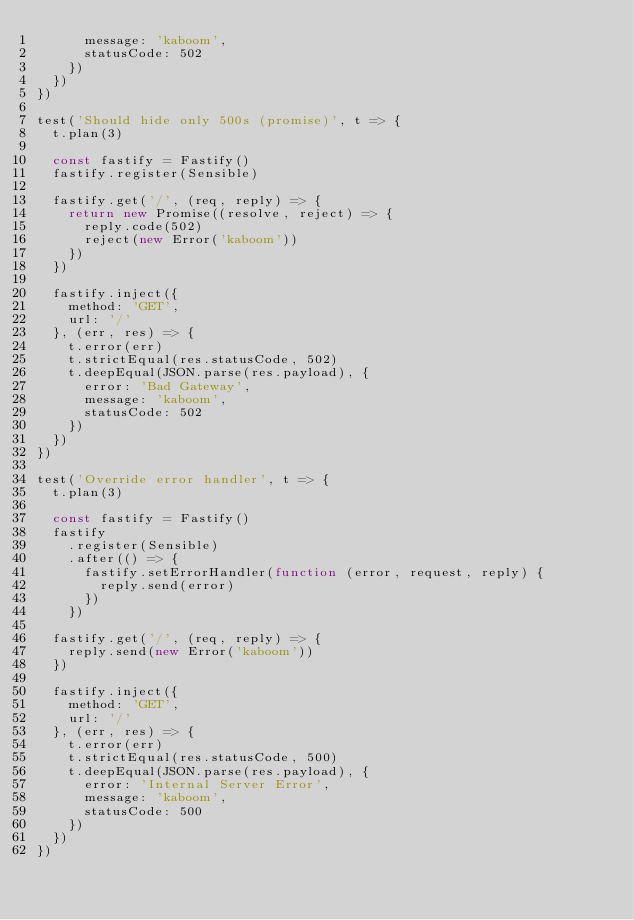Convert code to text. <code><loc_0><loc_0><loc_500><loc_500><_JavaScript_>      message: 'kaboom',
      statusCode: 502
    })
  })
})

test('Should hide only 500s (promise)', t => {
  t.plan(3)

  const fastify = Fastify()
  fastify.register(Sensible)

  fastify.get('/', (req, reply) => {
    return new Promise((resolve, reject) => {
      reply.code(502)
      reject(new Error('kaboom'))
    })
  })

  fastify.inject({
    method: 'GET',
    url: '/'
  }, (err, res) => {
    t.error(err)
    t.strictEqual(res.statusCode, 502)
    t.deepEqual(JSON.parse(res.payload), {
      error: 'Bad Gateway',
      message: 'kaboom',
      statusCode: 502
    })
  })
})

test('Override error handler', t => {
  t.plan(3)

  const fastify = Fastify()
  fastify
    .register(Sensible)
    .after(() => {
      fastify.setErrorHandler(function (error, request, reply) {
        reply.send(error)
      })
    })

  fastify.get('/', (req, reply) => {
    reply.send(new Error('kaboom'))
  })

  fastify.inject({
    method: 'GET',
    url: '/'
  }, (err, res) => {
    t.error(err)
    t.strictEqual(res.statusCode, 500)
    t.deepEqual(JSON.parse(res.payload), {
      error: 'Internal Server Error',
      message: 'kaboom',
      statusCode: 500
    })
  })
})
</code> 